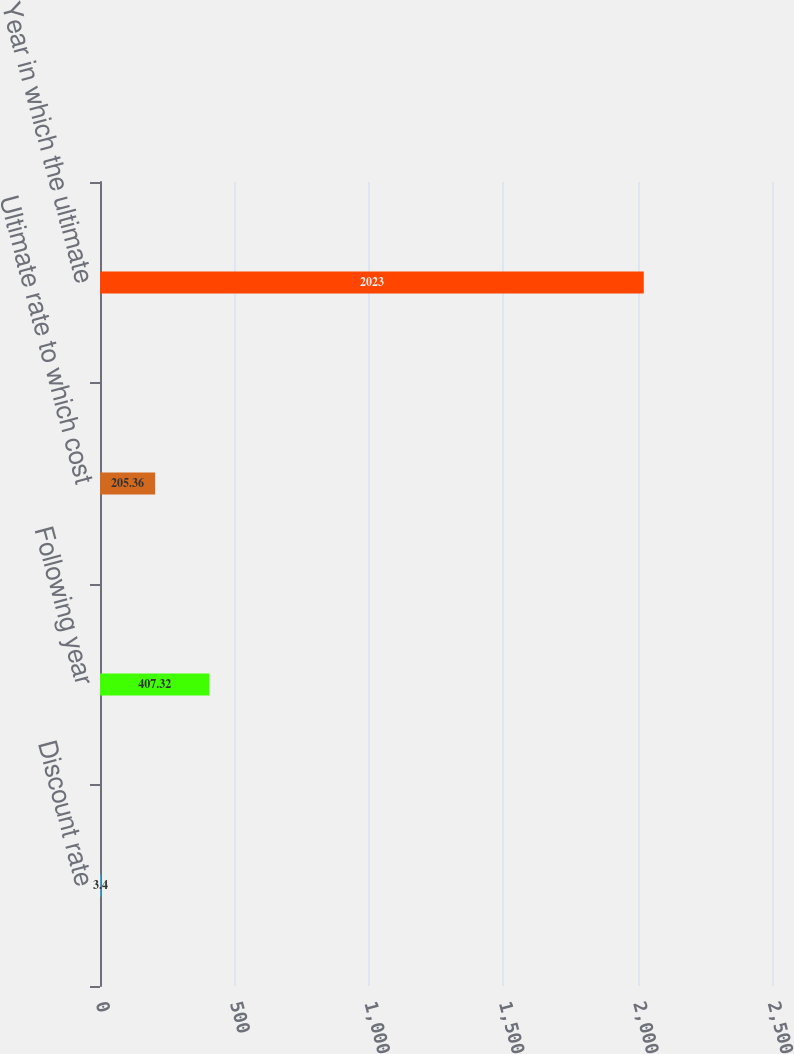Convert chart to OTSL. <chart><loc_0><loc_0><loc_500><loc_500><bar_chart><fcel>Discount rate<fcel>Following year<fcel>Ultimate rate to which cost<fcel>Year in which the ultimate<nl><fcel>3.4<fcel>407.32<fcel>205.36<fcel>2023<nl></chart> 